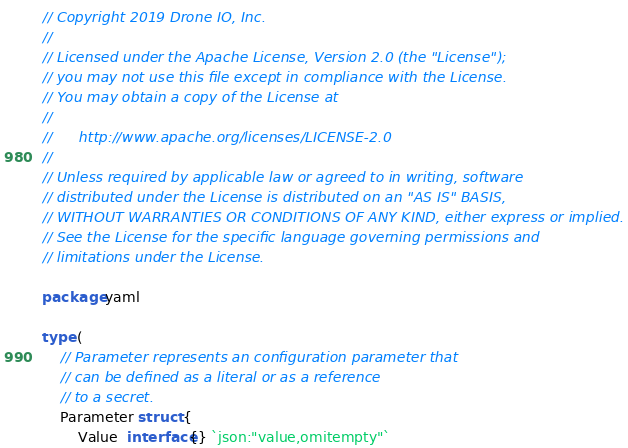Convert code to text. <code><loc_0><loc_0><loc_500><loc_500><_Go_>// Copyright 2019 Drone IO, Inc.
//
// Licensed under the Apache License, Version 2.0 (the "License");
// you may not use this file except in compliance with the License.
// You may obtain a copy of the License at
//
//      http://www.apache.org/licenses/LICENSE-2.0
//
// Unless required by applicable law or agreed to in writing, software
// distributed under the License is distributed on an "AS IS" BASIS,
// WITHOUT WARRANTIES OR CONDITIONS OF ANY KIND, either express or implied.
// See the License for the specific language governing permissions and
// limitations under the License.

package yaml

type (
	// Parameter represents an configuration parameter that
	// can be defined as a literal or as a reference
	// to a secret.
	Parameter struct {
		Value  interface{} `json:"value,omitempty"`</code> 